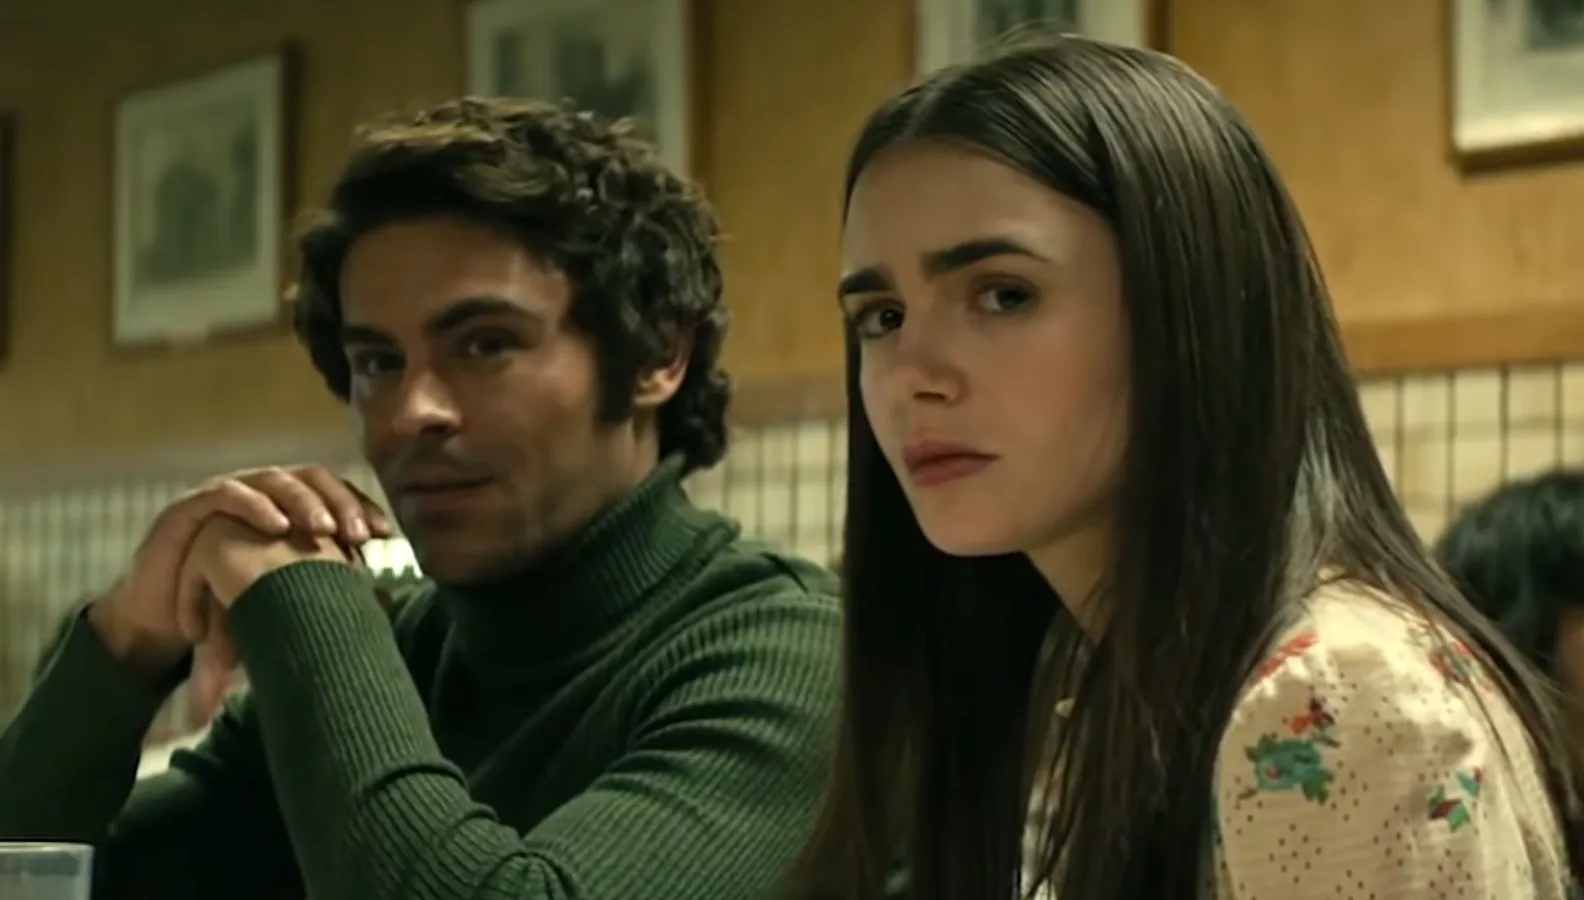What is the mood of the scene and how is it conveyed visually? The mood of the scene is contemplative and somber, conveyed through the actors' serious facial expressions and their off-camera gazes which imply a focus on something beyond the immediate setting. The diner's subdued lighting and the warm earthy color palette add to the ambience of introspection. The close proximity between the characters hints at a personal and potentially intense interaction. Are there any details in the image that suggest a time period or specific setting? While there are no explicit indicators of a specific time period, the style of clothing, with a classic turtleneck sweater and a blouse with a retro floral pattern, may imply a setting that's not contemporary. The diner's interior, though visible only in fragments, with its framed pictures and apparent wooden details, might suggest a timeless or past era, but the precise period remains ambiguous. 